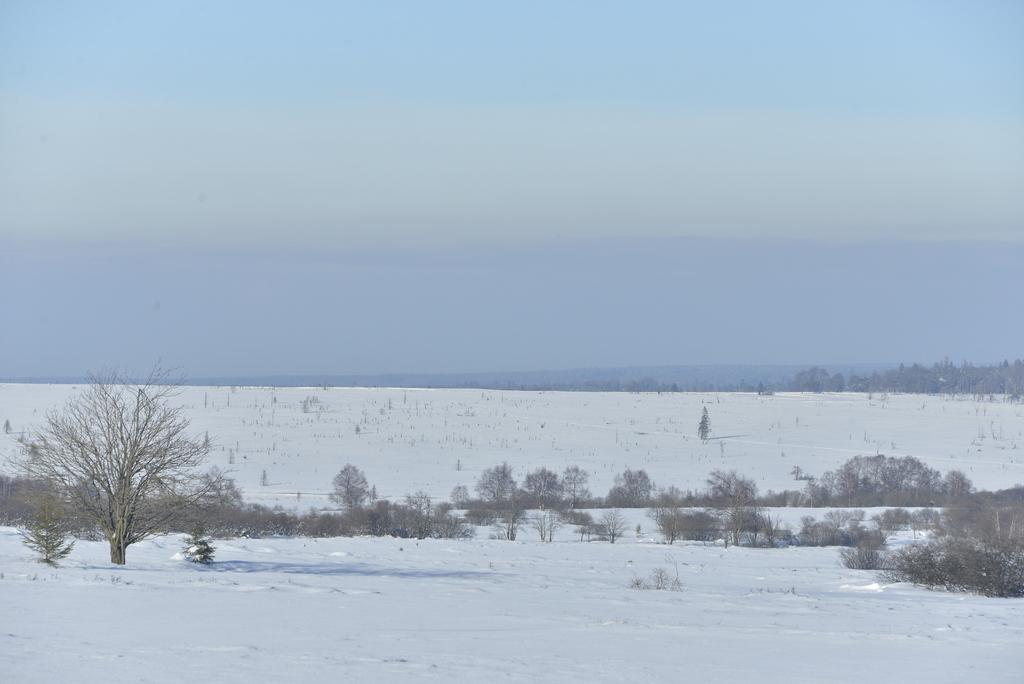What is the setting of the image? The image has an outside view. What can be seen in the foreground of the image? There are trees in the foreground of the image. What is visible in the background of the image? The sky is visible in the background of the image. How many people are in the crowd depicted in the image? There is no crowd present in the image; it features an outside view with trees in the foreground and the sky in the background. 